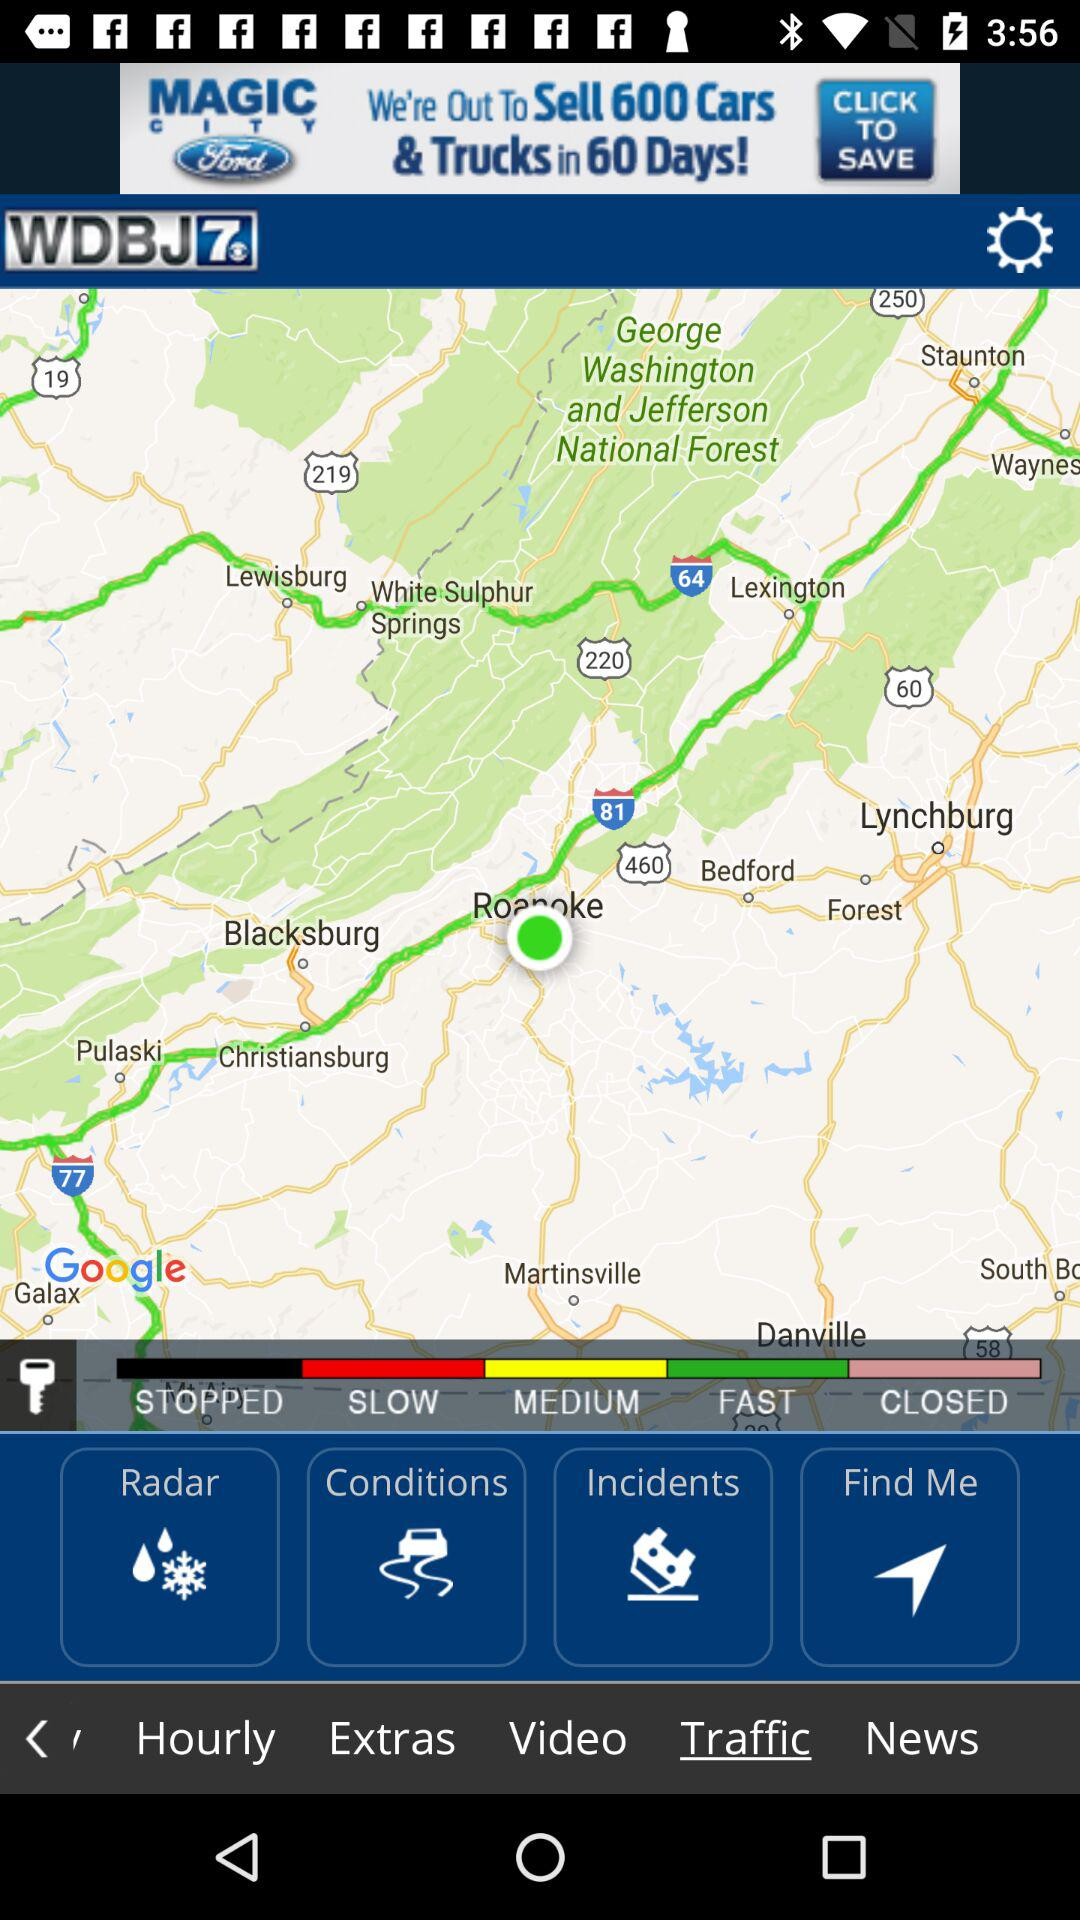How many traffic conditions are there?
Answer the question using a single word or phrase. 4 